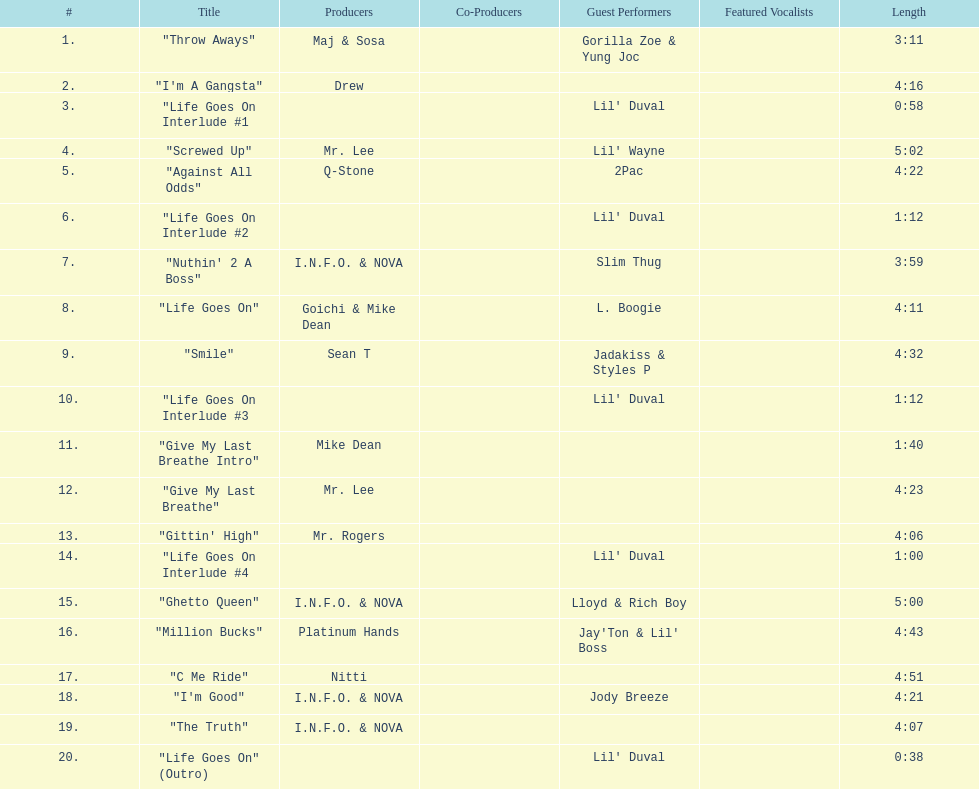Which tracks are longer than 4.00? "I'm A Gangsta", "Screwed Up", "Against All Odds", "Life Goes On", "Smile", "Give My Last Breathe", "Gittin' High", "Ghetto Queen", "Million Bucks", "C Me Ride", "I'm Good", "The Truth". Of those, which tracks are longer than 4.30? "Screwed Up", "Smile", "Ghetto Queen", "Million Bucks", "C Me Ride". Of those, which tracks are 5.00 or longer? "Screwed Up", "Ghetto Queen". Could you parse the entire table as a dict? {'header': ['#', 'Title', 'Producers', 'Co-Producers', 'Guest Performers', 'Featured Vocalists', 'Length'], 'rows': [['1.', '"Throw Aways"', 'Maj & Sosa', '', 'Gorilla Zoe & Yung Joc', '', '3:11'], ['2.', '"I\'m A Gangsta"', 'Drew', '', '', '', '4:16'], ['3.', '"Life Goes On Interlude #1', '', '', "Lil' Duval", '', '0:58'], ['4.', '"Screwed Up"', 'Mr. Lee', '', "Lil' Wayne", '', '5:02'], ['5.', '"Against All Odds"', 'Q-Stone', '', '2Pac', '', '4:22'], ['6.', '"Life Goes On Interlude #2', '', '', "Lil' Duval", '', '1:12'], ['7.', '"Nuthin\' 2 A Boss"', 'I.N.F.O. & NOVA', '', 'Slim Thug', '', '3:59'], ['8.', '"Life Goes On"', 'Goichi & Mike Dean', '', 'L. Boogie', '', '4:11'], ['9.', '"Smile"', 'Sean T', '', 'Jadakiss & Styles P', '', '4:32'], ['10.', '"Life Goes On Interlude #3', '', '', "Lil' Duval", '', '1:12'], ['11.', '"Give My Last Breathe Intro"', 'Mike Dean', '', '', '', '1:40'], ['12.', '"Give My Last Breathe"', 'Mr. Lee', '', '', '', '4:23'], ['13.', '"Gittin\' High"', 'Mr. Rogers', '', '', '', '4:06'], ['14.', '"Life Goes On Interlude #4', '', '', "Lil' Duval", '', '1:00'], ['15.', '"Ghetto Queen"', 'I.N.F.O. & NOVA', '', 'Lloyd & Rich Boy', '', '5:00'], ['16.', '"Million Bucks"', 'Platinum Hands', '', "Jay'Ton & Lil' Boss", '', '4:43'], ['17.', '"C Me Ride"', 'Nitti', '', '', '', '4:51'], ['18.', '"I\'m Good"', 'I.N.F.O. & NOVA', '', 'Jody Breeze', '', '4:21'], ['19.', '"The Truth"', 'I.N.F.O. & NOVA', '', '', '', '4:07'], ['20.', '"Life Goes On" (Outro)', '', '', "Lil' Duval", '', '0:38']]} Of those, which one is the longest? "Screwed Up". How long is that track? 5:02. 